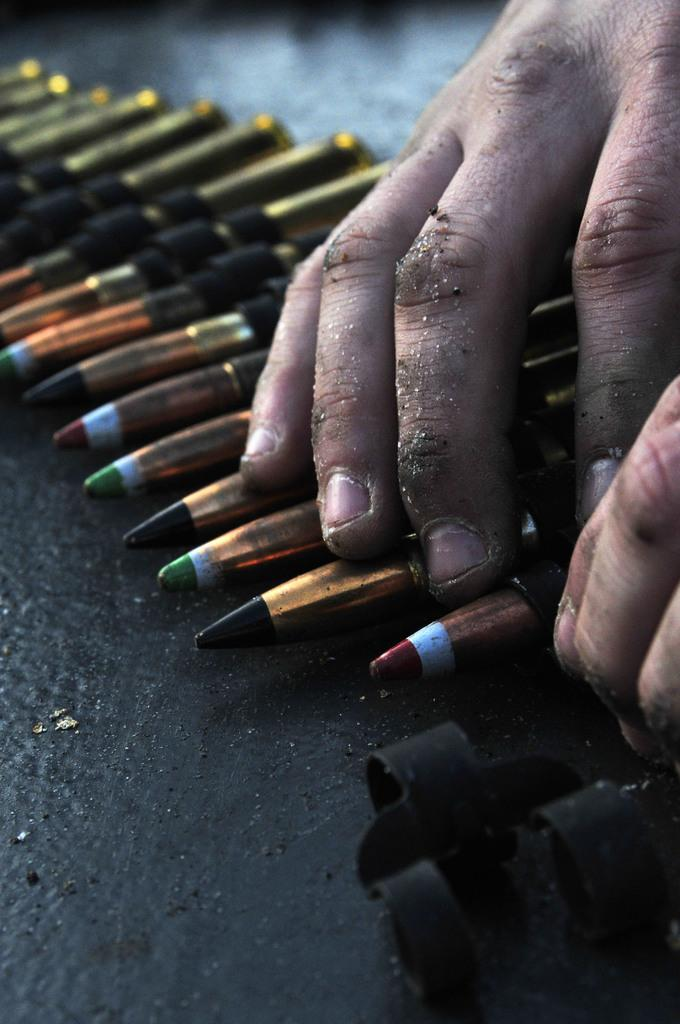What can be seen on the right side of the image? There are fingers of a person on the right side of the image. What objects are present on a platform in the image? There are color pencils on a platform in the image. What type of reaction can be seen on the person's foot in the image? There is no foot visible in the image, and therefore no reaction can be observed. 